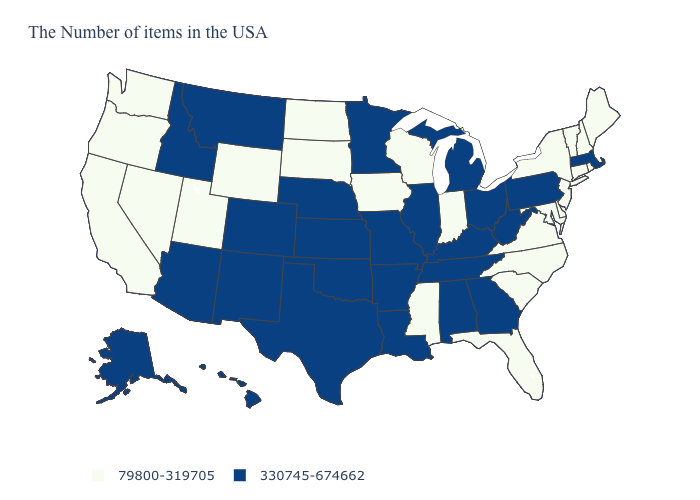Does Hawaii have the lowest value in the West?
Keep it brief. No. Is the legend a continuous bar?
Short answer required. No. What is the value of Wisconsin?
Answer briefly. 79800-319705. Does the first symbol in the legend represent the smallest category?
Give a very brief answer. Yes. Which states have the lowest value in the USA?
Keep it brief. Maine, Rhode Island, New Hampshire, Vermont, Connecticut, New York, New Jersey, Delaware, Maryland, Virginia, North Carolina, South Carolina, Florida, Indiana, Wisconsin, Mississippi, Iowa, South Dakota, North Dakota, Wyoming, Utah, Nevada, California, Washington, Oregon. What is the lowest value in the USA?
Be succinct. 79800-319705. Does West Virginia have the highest value in the USA?
Quick response, please. Yes. Does Wyoming have the lowest value in the West?
Short answer required. Yes. What is the highest value in states that border Louisiana?
Answer briefly. 330745-674662. Among the states that border Colorado , does Wyoming have the lowest value?
Short answer required. Yes. Among the states that border Nevada , does Utah have the highest value?
Give a very brief answer. No. Name the states that have a value in the range 330745-674662?
Give a very brief answer. Massachusetts, Pennsylvania, West Virginia, Ohio, Georgia, Michigan, Kentucky, Alabama, Tennessee, Illinois, Louisiana, Missouri, Arkansas, Minnesota, Kansas, Nebraska, Oklahoma, Texas, Colorado, New Mexico, Montana, Arizona, Idaho, Alaska, Hawaii. What is the highest value in the West ?
Keep it brief. 330745-674662. Does Minnesota have the same value as Mississippi?
Quick response, please. No. What is the value of Alabama?
Short answer required. 330745-674662. 